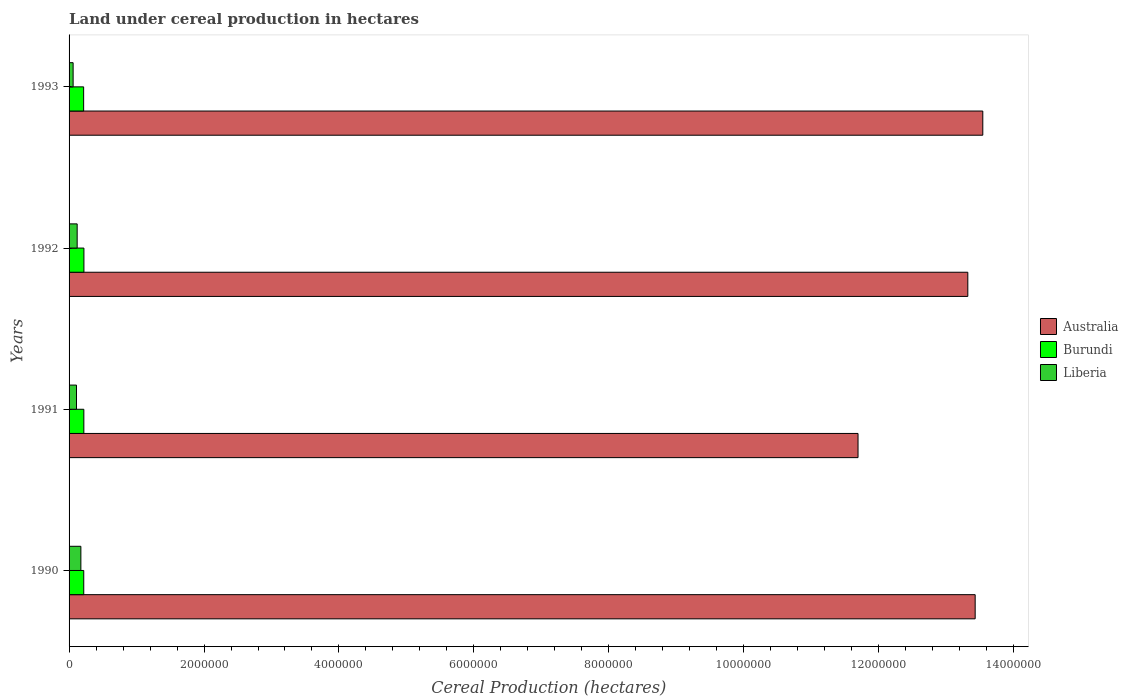How many different coloured bars are there?
Make the answer very short. 3. Are the number of bars per tick equal to the number of legend labels?
Make the answer very short. Yes. How many bars are there on the 4th tick from the bottom?
Your response must be concise. 3. In how many cases, is the number of bars for a given year not equal to the number of legend labels?
Keep it short and to the point. 0. What is the land under cereal production in Australia in 1990?
Your response must be concise. 1.34e+07. Across all years, what is the maximum land under cereal production in Liberia?
Ensure brevity in your answer.  1.75e+05. Across all years, what is the minimum land under cereal production in Australia?
Your answer should be compact. 1.17e+07. What is the total land under cereal production in Liberia in the graph?
Provide a short and direct response. 4.65e+05. What is the difference between the land under cereal production in Burundi in 1991 and that in 1993?
Offer a very short reply. 2959. What is the difference between the land under cereal production in Liberia in 1993 and the land under cereal production in Australia in 1991?
Keep it short and to the point. -1.16e+07. What is the average land under cereal production in Burundi per year?
Give a very brief answer. 2.18e+05. In the year 1992, what is the difference between the land under cereal production in Liberia and land under cereal production in Burundi?
Your response must be concise. -1.00e+05. What is the ratio of the land under cereal production in Burundi in 1990 to that in 1992?
Make the answer very short. 0.99. Is the difference between the land under cereal production in Liberia in 1991 and 1992 greater than the difference between the land under cereal production in Burundi in 1991 and 1992?
Offer a very short reply. No. What is the difference between the highest and the second highest land under cereal production in Liberia?
Ensure brevity in your answer.  5.50e+04. What is the difference between the highest and the lowest land under cereal production in Liberia?
Offer a terse response. 1.15e+05. What does the 2nd bar from the bottom in 1990 represents?
Your response must be concise. Burundi. Are all the bars in the graph horizontal?
Provide a short and direct response. Yes. Does the graph contain any zero values?
Ensure brevity in your answer.  No. Does the graph contain grids?
Provide a short and direct response. No. Where does the legend appear in the graph?
Offer a very short reply. Center right. How many legend labels are there?
Offer a terse response. 3. How are the legend labels stacked?
Give a very brief answer. Vertical. What is the title of the graph?
Offer a terse response. Land under cereal production in hectares. What is the label or title of the X-axis?
Offer a terse response. Cereal Production (hectares). What is the label or title of the Y-axis?
Offer a very short reply. Years. What is the Cereal Production (hectares) in Australia in 1990?
Your response must be concise. 1.34e+07. What is the Cereal Production (hectares) of Burundi in 1990?
Your answer should be compact. 2.18e+05. What is the Cereal Production (hectares) of Liberia in 1990?
Ensure brevity in your answer.  1.75e+05. What is the Cereal Production (hectares) of Australia in 1991?
Your response must be concise. 1.17e+07. What is the Cereal Production (hectares) of Burundi in 1991?
Make the answer very short. 2.19e+05. What is the Cereal Production (hectares) of Liberia in 1991?
Your answer should be very brief. 1.10e+05. What is the Cereal Production (hectares) of Australia in 1992?
Offer a very short reply. 1.33e+07. What is the Cereal Production (hectares) in Burundi in 1992?
Your answer should be very brief. 2.20e+05. What is the Cereal Production (hectares) of Australia in 1993?
Provide a succinct answer. 1.35e+07. What is the Cereal Production (hectares) in Burundi in 1993?
Give a very brief answer. 2.16e+05. What is the Cereal Production (hectares) in Liberia in 1993?
Your response must be concise. 6.00e+04. Across all years, what is the maximum Cereal Production (hectares) in Australia?
Offer a terse response. 1.35e+07. Across all years, what is the maximum Cereal Production (hectares) of Burundi?
Keep it short and to the point. 2.20e+05. Across all years, what is the maximum Cereal Production (hectares) of Liberia?
Give a very brief answer. 1.75e+05. Across all years, what is the minimum Cereal Production (hectares) of Australia?
Offer a terse response. 1.17e+07. Across all years, what is the minimum Cereal Production (hectares) of Burundi?
Make the answer very short. 2.16e+05. Across all years, what is the minimum Cereal Production (hectares) of Liberia?
Provide a short and direct response. 6.00e+04. What is the total Cereal Production (hectares) in Australia in the graph?
Ensure brevity in your answer.  5.20e+07. What is the total Cereal Production (hectares) of Burundi in the graph?
Your response must be concise. 8.73e+05. What is the total Cereal Production (hectares) of Liberia in the graph?
Ensure brevity in your answer.  4.65e+05. What is the difference between the Cereal Production (hectares) of Australia in 1990 and that in 1991?
Offer a very short reply. 1.74e+06. What is the difference between the Cereal Production (hectares) of Burundi in 1990 and that in 1991?
Your answer should be very brief. -1500. What is the difference between the Cereal Production (hectares) in Liberia in 1990 and that in 1991?
Provide a short and direct response. 6.50e+04. What is the difference between the Cereal Production (hectares) of Australia in 1990 and that in 1992?
Offer a very short reply. 1.09e+05. What is the difference between the Cereal Production (hectares) in Burundi in 1990 and that in 1992?
Give a very brief answer. -2500. What is the difference between the Cereal Production (hectares) in Liberia in 1990 and that in 1992?
Ensure brevity in your answer.  5.50e+04. What is the difference between the Cereal Production (hectares) of Australia in 1990 and that in 1993?
Keep it short and to the point. -1.13e+05. What is the difference between the Cereal Production (hectares) in Burundi in 1990 and that in 1993?
Provide a succinct answer. 1459. What is the difference between the Cereal Production (hectares) of Liberia in 1990 and that in 1993?
Provide a short and direct response. 1.15e+05. What is the difference between the Cereal Production (hectares) of Australia in 1991 and that in 1992?
Make the answer very short. -1.63e+06. What is the difference between the Cereal Production (hectares) in Burundi in 1991 and that in 1992?
Your answer should be compact. -1000. What is the difference between the Cereal Production (hectares) of Australia in 1991 and that in 1993?
Your answer should be very brief. -1.85e+06. What is the difference between the Cereal Production (hectares) in Burundi in 1991 and that in 1993?
Provide a succinct answer. 2959. What is the difference between the Cereal Production (hectares) in Liberia in 1991 and that in 1993?
Give a very brief answer. 5.00e+04. What is the difference between the Cereal Production (hectares) in Australia in 1992 and that in 1993?
Ensure brevity in your answer.  -2.22e+05. What is the difference between the Cereal Production (hectares) of Burundi in 1992 and that in 1993?
Your answer should be compact. 3959. What is the difference between the Cereal Production (hectares) in Liberia in 1992 and that in 1993?
Your answer should be very brief. 6.00e+04. What is the difference between the Cereal Production (hectares) of Australia in 1990 and the Cereal Production (hectares) of Burundi in 1991?
Your response must be concise. 1.32e+07. What is the difference between the Cereal Production (hectares) of Australia in 1990 and the Cereal Production (hectares) of Liberia in 1991?
Ensure brevity in your answer.  1.33e+07. What is the difference between the Cereal Production (hectares) of Burundi in 1990 and the Cereal Production (hectares) of Liberia in 1991?
Give a very brief answer. 1.08e+05. What is the difference between the Cereal Production (hectares) in Australia in 1990 and the Cereal Production (hectares) in Burundi in 1992?
Provide a short and direct response. 1.32e+07. What is the difference between the Cereal Production (hectares) in Australia in 1990 and the Cereal Production (hectares) in Liberia in 1992?
Your answer should be compact. 1.33e+07. What is the difference between the Cereal Production (hectares) in Burundi in 1990 and the Cereal Production (hectares) in Liberia in 1992?
Provide a short and direct response. 9.75e+04. What is the difference between the Cereal Production (hectares) of Australia in 1990 and the Cereal Production (hectares) of Burundi in 1993?
Offer a terse response. 1.32e+07. What is the difference between the Cereal Production (hectares) of Australia in 1990 and the Cereal Production (hectares) of Liberia in 1993?
Provide a short and direct response. 1.34e+07. What is the difference between the Cereal Production (hectares) in Burundi in 1990 and the Cereal Production (hectares) in Liberia in 1993?
Provide a short and direct response. 1.58e+05. What is the difference between the Cereal Production (hectares) of Australia in 1991 and the Cereal Production (hectares) of Burundi in 1992?
Your answer should be very brief. 1.15e+07. What is the difference between the Cereal Production (hectares) in Australia in 1991 and the Cereal Production (hectares) in Liberia in 1992?
Your response must be concise. 1.16e+07. What is the difference between the Cereal Production (hectares) in Burundi in 1991 and the Cereal Production (hectares) in Liberia in 1992?
Offer a very short reply. 9.90e+04. What is the difference between the Cereal Production (hectares) of Australia in 1991 and the Cereal Production (hectares) of Burundi in 1993?
Offer a terse response. 1.15e+07. What is the difference between the Cereal Production (hectares) in Australia in 1991 and the Cereal Production (hectares) in Liberia in 1993?
Provide a succinct answer. 1.16e+07. What is the difference between the Cereal Production (hectares) in Burundi in 1991 and the Cereal Production (hectares) in Liberia in 1993?
Your answer should be compact. 1.59e+05. What is the difference between the Cereal Production (hectares) of Australia in 1992 and the Cereal Production (hectares) of Burundi in 1993?
Offer a terse response. 1.31e+07. What is the difference between the Cereal Production (hectares) in Australia in 1992 and the Cereal Production (hectares) in Liberia in 1993?
Make the answer very short. 1.33e+07. What is the difference between the Cereal Production (hectares) in Burundi in 1992 and the Cereal Production (hectares) in Liberia in 1993?
Give a very brief answer. 1.60e+05. What is the average Cereal Production (hectares) of Australia per year?
Your response must be concise. 1.30e+07. What is the average Cereal Production (hectares) of Burundi per year?
Provide a succinct answer. 2.18e+05. What is the average Cereal Production (hectares) of Liberia per year?
Your answer should be compact. 1.16e+05. In the year 1990, what is the difference between the Cereal Production (hectares) of Australia and Cereal Production (hectares) of Burundi?
Your answer should be very brief. 1.32e+07. In the year 1990, what is the difference between the Cereal Production (hectares) of Australia and Cereal Production (hectares) of Liberia?
Provide a short and direct response. 1.33e+07. In the year 1990, what is the difference between the Cereal Production (hectares) of Burundi and Cereal Production (hectares) of Liberia?
Make the answer very short. 4.25e+04. In the year 1991, what is the difference between the Cereal Production (hectares) of Australia and Cereal Production (hectares) of Burundi?
Make the answer very short. 1.15e+07. In the year 1991, what is the difference between the Cereal Production (hectares) of Australia and Cereal Production (hectares) of Liberia?
Provide a short and direct response. 1.16e+07. In the year 1991, what is the difference between the Cereal Production (hectares) in Burundi and Cereal Production (hectares) in Liberia?
Ensure brevity in your answer.  1.09e+05. In the year 1992, what is the difference between the Cereal Production (hectares) in Australia and Cereal Production (hectares) in Burundi?
Your response must be concise. 1.31e+07. In the year 1992, what is the difference between the Cereal Production (hectares) in Australia and Cereal Production (hectares) in Liberia?
Keep it short and to the point. 1.32e+07. In the year 1993, what is the difference between the Cereal Production (hectares) in Australia and Cereal Production (hectares) in Burundi?
Offer a terse response. 1.33e+07. In the year 1993, what is the difference between the Cereal Production (hectares) in Australia and Cereal Production (hectares) in Liberia?
Offer a very short reply. 1.35e+07. In the year 1993, what is the difference between the Cereal Production (hectares) in Burundi and Cereal Production (hectares) in Liberia?
Make the answer very short. 1.56e+05. What is the ratio of the Cereal Production (hectares) in Australia in 1990 to that in 1991?
Your response must be concise. 1.15. What is the ratio of the Cereal Production (hectares) of Burundi in 1990 to that in 1991?
Provide a succinct answer. 0.99. What is the ratio of the Cereal Production (hectares) in Liberia in 1990 to that in 1991?
Provide a short and direct response. 1.59. What is the ratio of the Cereal Production (hectares) of Australia in 1990 to that in 1992?
Offer a terse response. 1.01. What is the ratio of the Cereal Production (hectares) of Liberia in 1990 to that in 1992?
Ensure brevity in your answer.  1.46. What is the ratio of the Cereal Production (hectares) of Australia in 1990 to that in 1993?
Your answer should be very brief. 0.99. What is the ratio of the Cereal Production (hectares) in Burundi in 1990 to that in 1993?
Ensure brevity in your answer.  1.01. What is the ratio of the Cereal Production (hectares) in Liberia in 1990 to that in 1993?
Your answer should be very brief. 2.92. What is the ratio of the Cereal Production (hectares) of Australia in 1991 to that in 1992?
Keep it short and to the point. 0.88. What is the ratio of the Cereal Production (hectares) in Burundi in 1991 to that in 1992?
Provide a succinct answer. 1. What is the ratio of the Cereal Production (hectares) in Liberia in 1991 to that in 1992?
Ensure brevity in your answer.  0.92. What is the ratio of the Cereal Production (hectares) of Australia in 1991 to that in 1993?
Provide a short and direct response. 0.86. What is the ratio of the Cereal Production (hectares) in Burundi in 1991 to that in 1993?
Provide a short and direct response. 1.01. What is the ratio of the Cereal Production (hectares) of Liberia in 1991 to that in 1993?
Provide a short and direct response. 1.83. What is the ratio of the Cereal Production (hectares) of Australia in 1992 to that in 1993?
Offer a terse response. 0.98. What is the ratio of the Cereal Production (hectares) in Burundi in 1992 to that in 1993?
Keep it short and to the point. 1.02. What is the difference between the highest and the second highest Cereal Production (hectares) of Australia?
Keep it short and to the point. 1.13e+05. What is the difference between the highest and the second highest Cereal Production (hectares) in Liberia?
Offer a terse response. 5.50e+04. What is the difference between the highest and the lowest Cereal Production (hectares) of Australia?
Ensure brevity in your answer.  1.85e+06. What is the difference between the highest and the lowest Cereal Production (hectares) of Burundi?
Keep it short and to the point. 3959. What is the difference between the highest and the lowest Cereal Production (hectares) in Liberia?
Provide a succinct answer. 1.15e+05. 